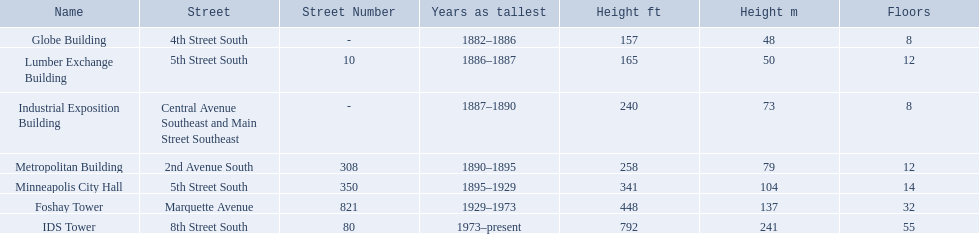Which buildings have the same number of floors as another building? Globe Building, Lumber Exchange Building, Industrial Exposition Building, Metropolitan Building. Of those, which has the same as the lumber exchange building? Metropolitan Building. 